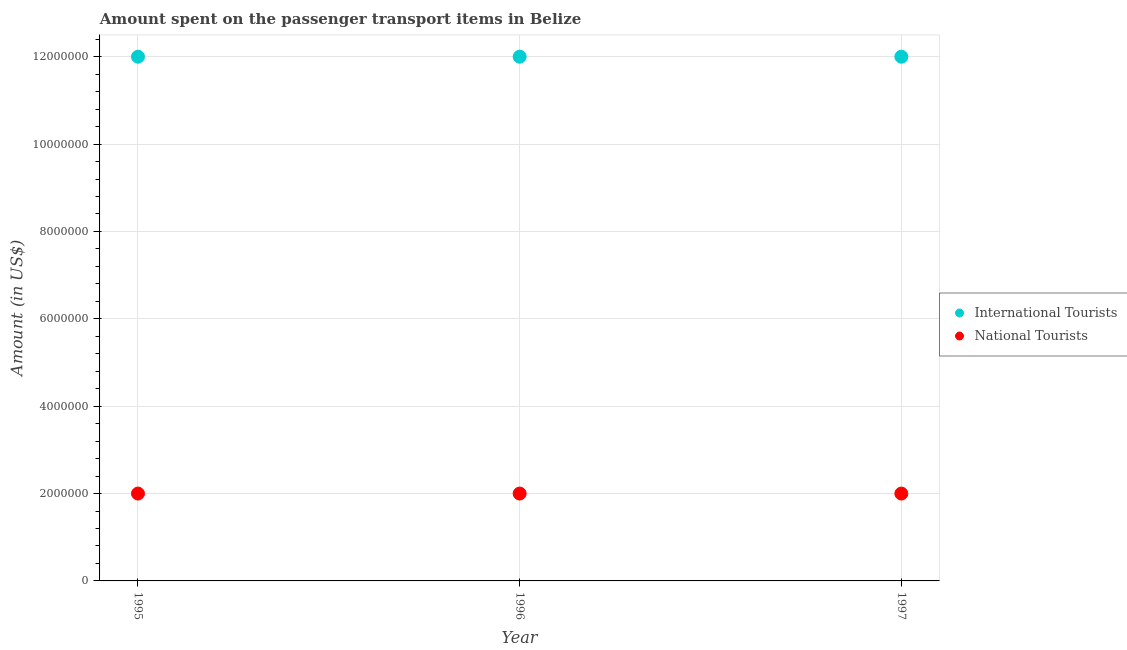What is the amount spent on transport items of international tourists in 1996?
Provide a succinct answer. 1.20e+07. Across all years, what is the maximum amount spent on transport items of national tourists?
Make the answer very short. 2.00e+06. Across all years, what is the minimum amount spent on transport items of national tourists?
Provide a succinct answer. 2.00e+06. In which year was the amount spent on transport items of international tourists maximum?
Your response must be concise. 1995. In which year was the amount spent on transport items of national tourists minimum?
Your response must be concise. 1995. What is the total amount spent on transport items of international tourists in the graph?
Keep it short and to the point. 3.60e+07. What is the difference between the amount spent on transport items of national tourists in 1995 and that in 1997?
Offer a terse response. 0. What is the difference between the amount spent on transport items of national tourists in 1996 and the amount spent on transport items of international tourists in 1995?
Give a very brief answer. -1.00e+07. In the year 1995, what is the difference between the amount spent on transport items of international tourists and amount spent on transport items of national tourists?
Your response must be concise. 1.00e+07. In how many years, is the amount spent on transport items of international tourists greater than 2400000 US$?
Provide a short and direct response. 3. What is the ratio of the amount spent on transport items of international tourists in 1995 to that in 1996?
Your answer should be compact. 1. Is the difference between the amount spent on transport items of international tourists in 1996 and 1997 greater than the difference between the amount spent on transport items of national tourists in 1996 and 1997?
Give a very brief answer. No. In how many years, is the amount spent on transport items of national tourists greater than the average amount spent on transport items of national tourists taken over all years?
Offer a terse response. 0. Does the amount spent on transport items of international tourists monotonically increase over the years?
Your answer should be very brief. No. Is the amount spent on transport items of international tourists strictly less than the amount spent on transport items of national tourists over the years?
Your answer should be compact. No. How many dotlines are there?
Give a very brief answer. 2. How many years are there in the graph?
Keep it short and to the point. 3. Are the values on the major ticks of Y-axis written in scientific E-notation?
Your answer should be compact. No. Does the graph contain any zero values?
Your answer should be very brief. No. Does the graph contain grids?
Make the answer very short. Yes. Where does the legend appear in the graph?
Give a very brief answer. Center right. What is the title of the graph?
Offer a terse response. Amount spent on the passenger transport items in Belize. Does "Excluding technical cooperation" appear as one of the legend labels in the graph?
Provide a short and direct response. No. What is the Amount (in US$) in International Tourists in 1995?
Your answer should be compact. 1.20e+07. What is the Amount (in US$) in National Tourists in 1995?
Make the answer very short. 2.00e+06. What is the Amount (in US$) in International Tourists in 1996?
Your answer should be compact. 1.20e+07. What is the Amount (in US$) in National Tourists in 1996?
Make the answer very short. 2.00e+06. Across all years, what is the minimum Amount (in US$) in National Tourists?
Ensure brevity in your answer.  2.00e+06. What is the total Amount (in US$) in International Tourists in the graph?
Give a very brief answer. 3.60e+07. What is the difference between the Amount (in US$) of International Tourists in 1995 and that in 1996?
Your response must be concise. 0. What is the difference between the Amount (in US$) in National Tourists in 1995 and that in 1996?
Ensure brevity in your answer.  0. What is the difference between the Amount (in US$) in International Tourists in 1995 and that in 1997?
Offer a terse response. 0. What is the difference between the Amount (in US$) in National Tourists in 1995 and that in 1997?
Your response must be concise. 0. What is the difference between the Amount (in US$) in International Tourists in 1995 and the Amount (in US$) in National Tourists in 1997?
Your answer should be compact. 1.00e+07. What is the average Amount (in US$) in International Tourists per year?
Ensure brevity in your answer.  1.20e+07. In the year 1996, what is the difference between the Amount (in US$) in International Tourists and Amount (in US$) in National Tourists?
Keep it short and to the point. 1.00e+07. What is the ratio of the Amount (in US$) of International Tourists in 1996 to that in 1997?
Provide a short and direct response. 1. What is the ratio of the Amount (in US$) in National Tourists in 1996 to that in 1997?
Give a very brief answer. 1. 